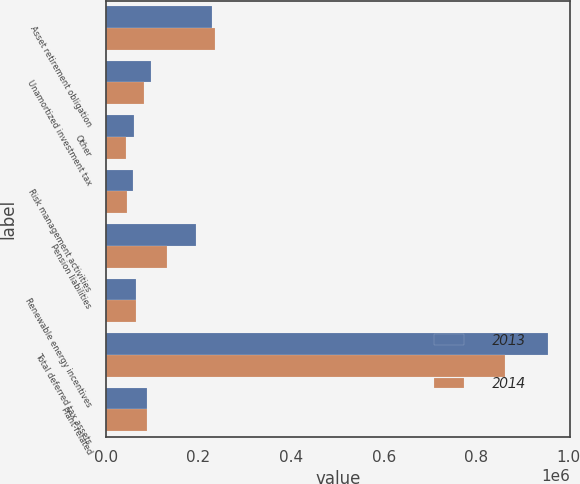Convert chart. <chart><loc_0><loc_0><loc_500><loc_500><stacked_bar_chart><ecel><fcel>Asset retirement obligation<fcel>Unamortized investment tax<fcel>Other<fcel>Risk management activities<fcel>Pension liabilities<fcel>Renewable energy incentives<fcel>Total deferred tax assets<fcel>Plant-related<nl><fcel>2013<fcel>229772<fcel>96232<fcel>60409<fcel>57505<fcel>194541<fcel>65169<fcel>955503<fcel>89174<nl><fcel>2014<fcel>235959<fcel>82116<fcel>42609<fcel>44920<fcel>132263<fcel>65434<fcel>862215<fcel>89174<nl></chart> 